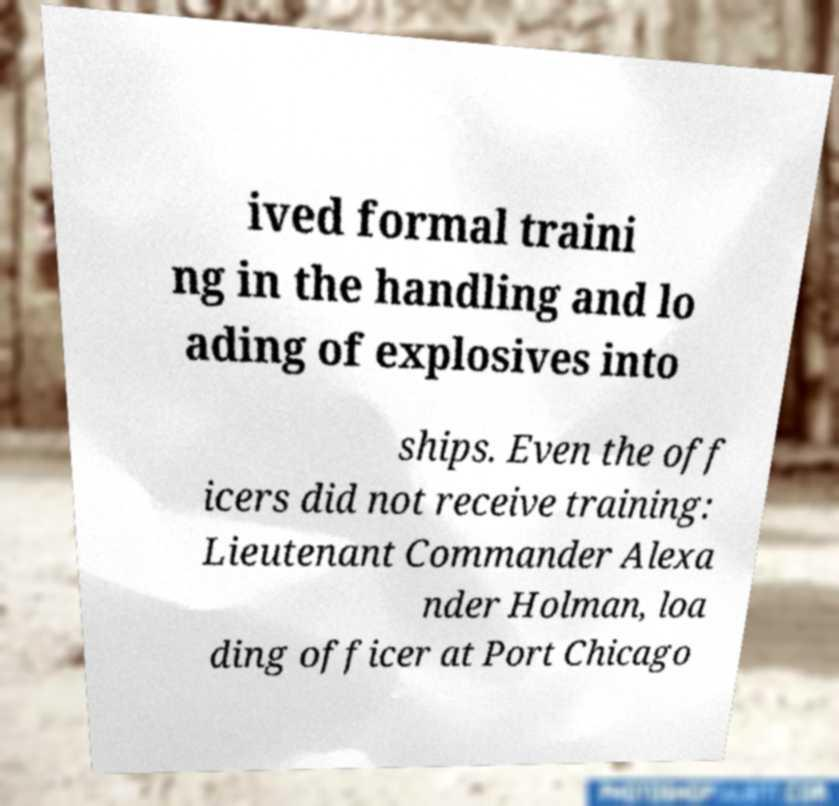Could you extract and type out the text from this image? ived formal traini ng in the handling and lo ading of explosives into ships. Even the off icers did not receive training: Lieutenant Commander Alexa nder Holman, loa ding officer at Port Chicago 